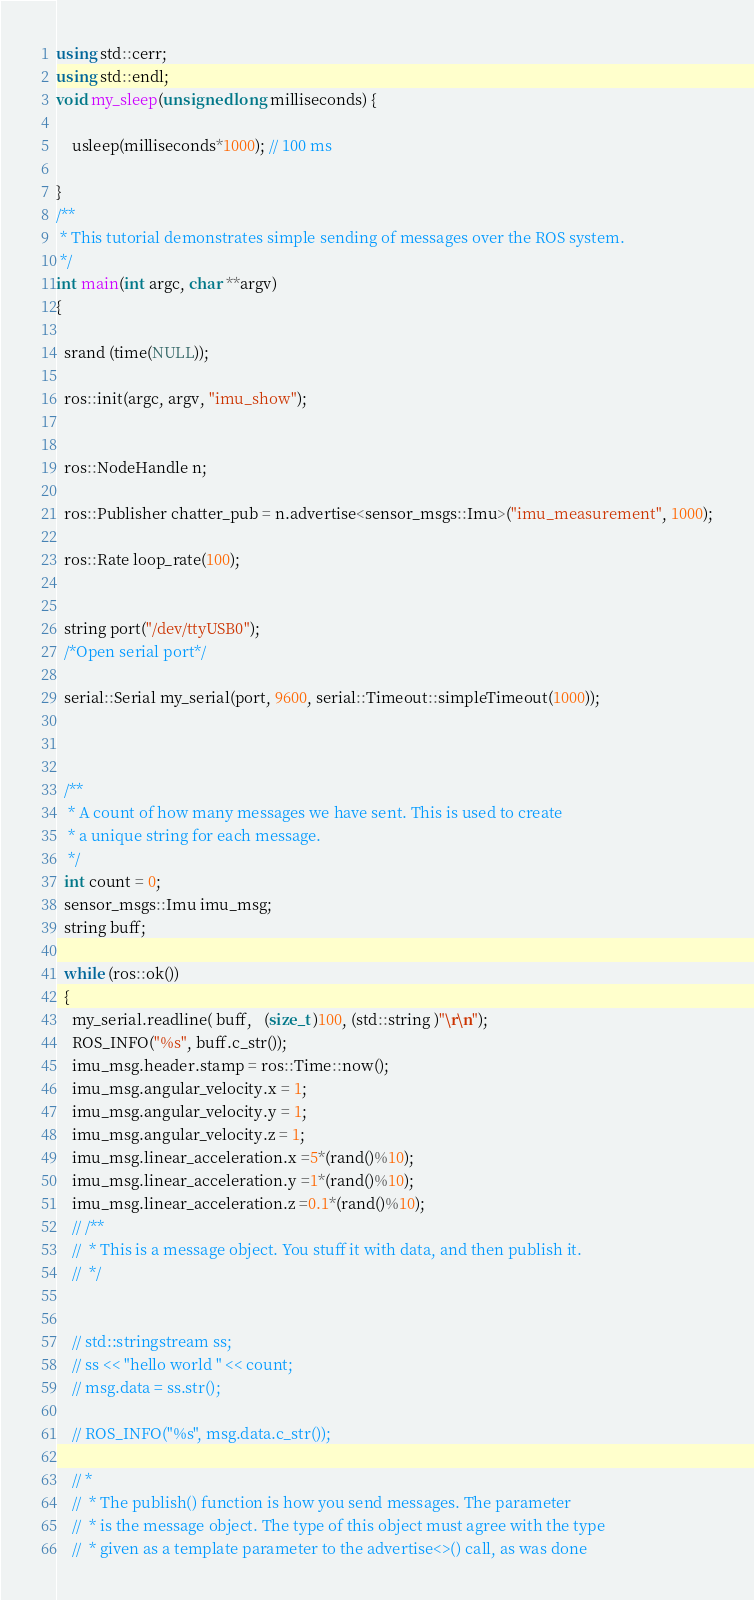<code> <loc_0><loc_0><loc_500><loc_500><_C++_>using std::cerr;
using std::endl;
void my_sleep(unsigned long milliseconds) {

    usleep(milliseconds*1000); // 100 ms

}
/**
 * This tutorial demonstrates simple sending of messages over the ROS system.
 */
int main(int argc, char **argv)
{

  srand (time(NULL));

  ros::init(argc, argv, "imu_show");


  ros::NodeHandle n;

  ros::Publisher chatter_pub = n.advertise<sensor_msgs::Imu>("imu_measurement", 1000);

  ros::Rate loop_rate(100);

  
  string port("/dev/ttyUSB0");
  /*Open serial port*/
 
  serial::Serial my_serial(port, 9600, serial::Timeout::simpleTimeout(1000));
  
  

  /**
   * A count of how many messages we have sent. This is used to create
   * a unique string for each message.
   */
  int count = 0;
  sensor_msgs::Imu imu_msg;
  string buff;

  while (ros::ok())
  {
    my_serial.readline( buff,   (size_t )100, (std::string )"\r\n");
    ROS_INFO("%s", buff.c_str());
    imu_msg.header.stamp = ros::Time::now();
    imu_msg.angular_velocity.x = 1;
    imu_msg.angular_velocity.y = 1;
    imu_msg.angular_velocity.z = 1;
    imu_msg.linear_acceleration.x =5*(rand()%10);
    imu_msg.linear_acceleration.y =1*(rand()%10);
    imu_msg.linear_acceleration.z =0.1*(rand()%10);
    // /**
    //  * This is a message object. You stuff it with data, and then publish it.
    //  */
    

    // std::stringstream ss;
    // ss << "hello world " << count;
    // msg.data = ss.str();

    // ROS_INFO("%s", msg.data.c_str());

    // *
    //  * The publish() function is how you send messages. The parameter
    //  * is the message object. The type of this object must agree with the type
    //  * given as a template parameter to the advertise<>() call, as was done</code> 